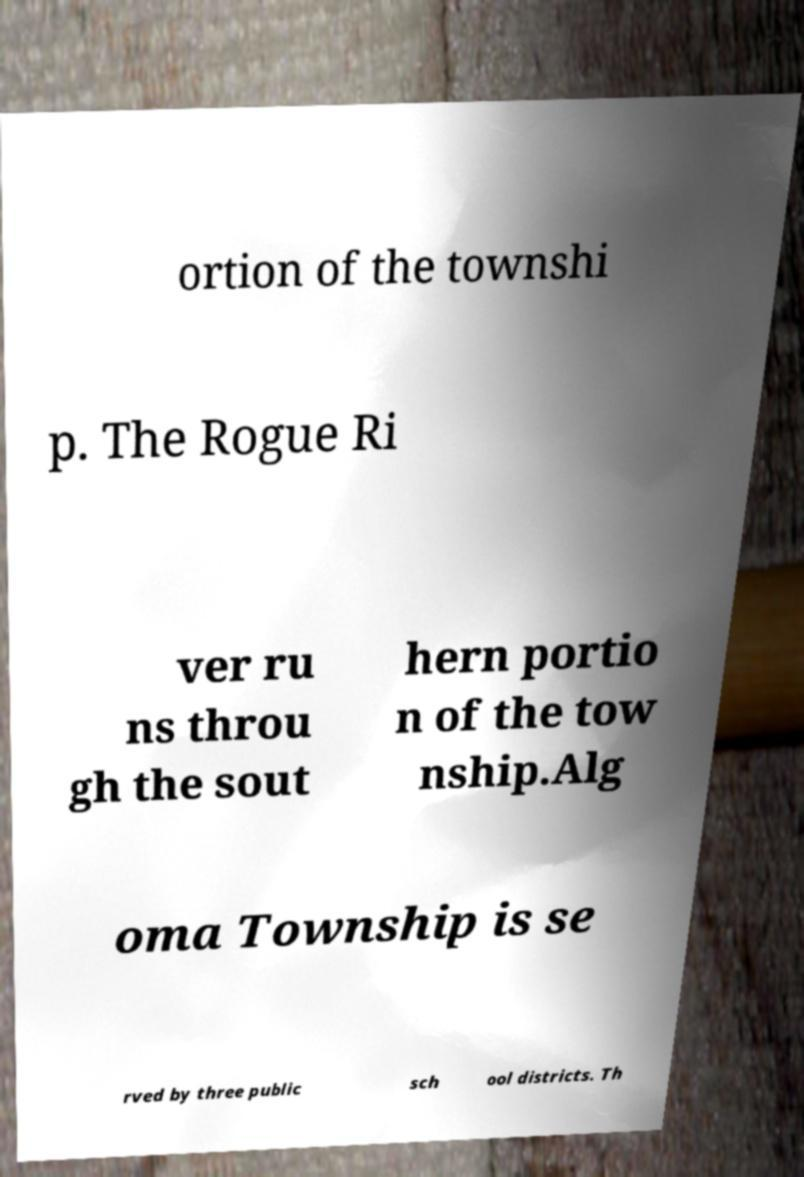Can you accurately transcribe the text from the provided image for me? ortion of the townshi p. The Rogue Ri ver ru ns throu gh the sout hern portio n of the tow nship.Alg oma Township is se rved by three public sch ool districts. Th 